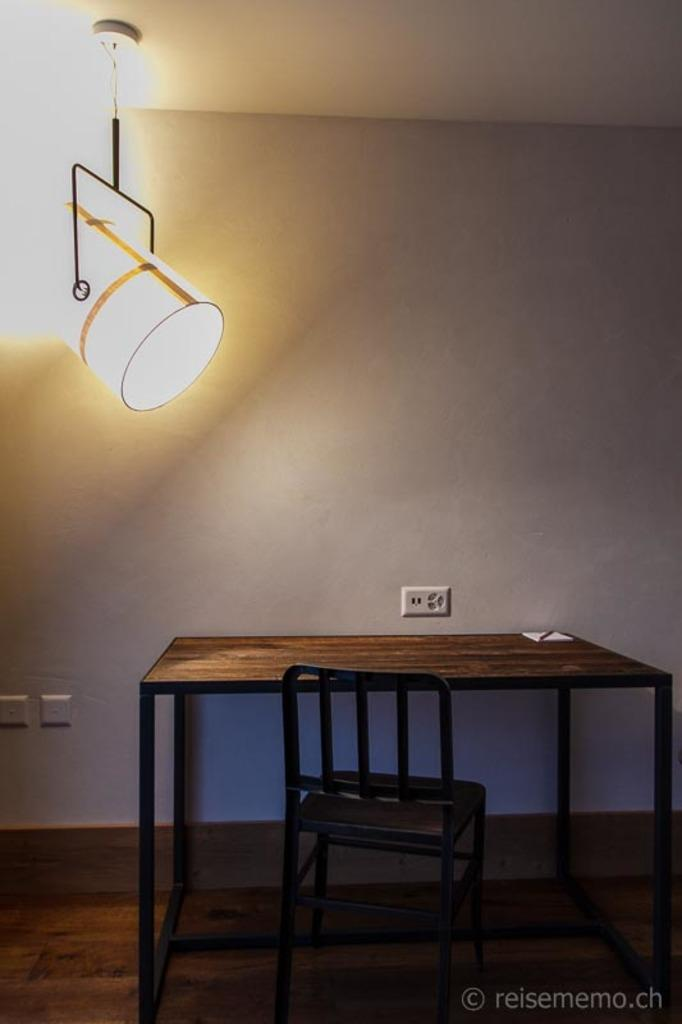What piece of furniture is present in the image? There is a table in the image. What is placed on the table? There is an object on the table. What type of seating is visible in the image? There is a chair in the image. What can be seen at the top of the image? There is a light at the top of the image. What is located on the wall in the background of the image? There is a switch board on the wall in the background of the image. How does the unit walk around in the image? There is no unit present in the image, and therefore no such activity can be observed. 